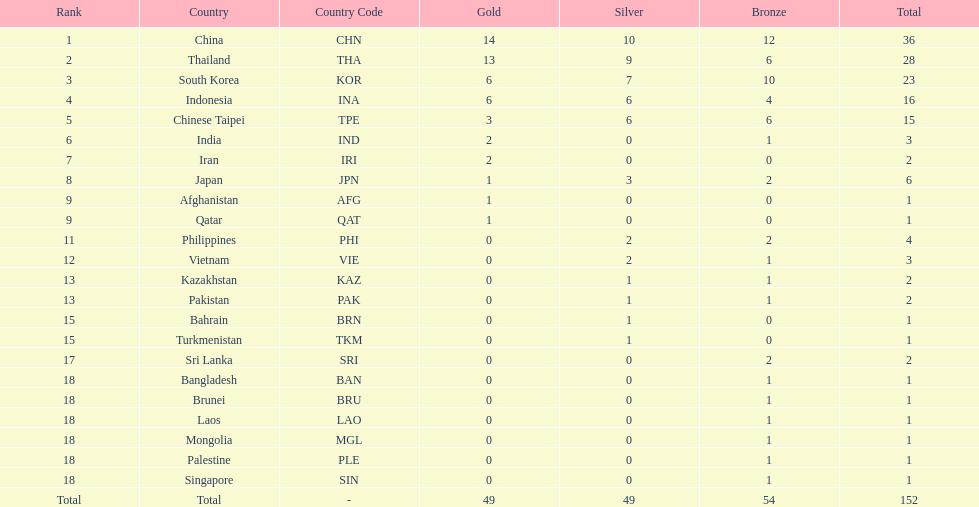Which countries won the same number of gold medals as japan? Afghanistan (AFG), Qatar (QAT). 